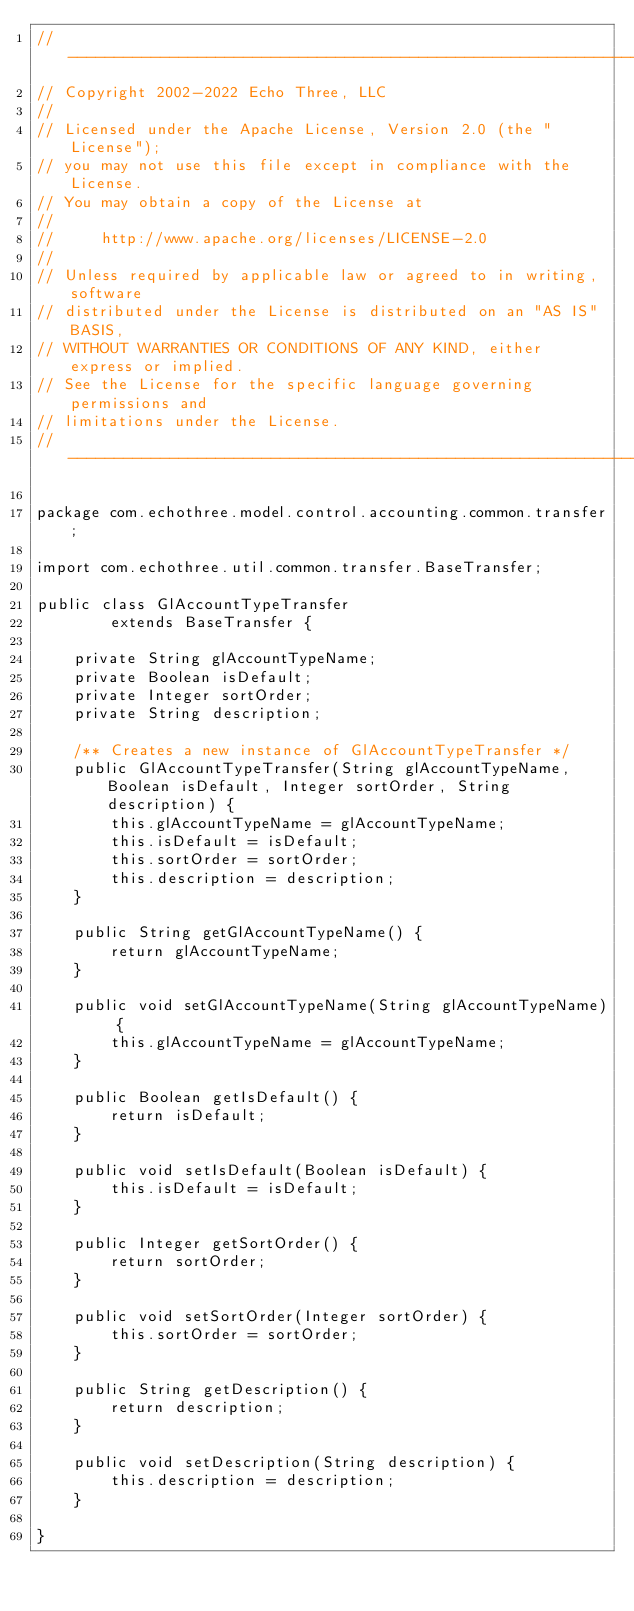Convert code to text. <code><loc_0><loc_0><loc_500><loc_500><_Java_>// --------------------------------------------------------------------------------
// Copyright 2002-2022 Echo Three, LLC
//
// Licensed under the Apache License, Version 2.0 (the "License");
// you may not use this file except in compliance with the License.
// You may obtain a copy of the License at
//
//     http://www.apache.org/licenses/LICENSE-2.0
//
// Unless required by applicable law or agreed to in writing, software
// distributed under the License is distributed on an "AS IS" BASIS,
// WITHOUT WARRANTIES OR CONDITIONS OF ANY KIND, either express or implied.
// See the License for the specific language governing permissions and
// limitations under the License.
// --------------------------------------------------------------------------------

package com.echothree.model.control.accounting.common.transfer;

import com.echothree.util.common.transfer.BaseTransfer;

public class GlAccountTypeTransfer
        extends BaseTransfer {
    
    private String glAccountTypeName;
    private Boolean isDefault;
    private Integer sortOrder;
    private String description;
    
    /** Creates a new instance of GlAccountTypeTransfer */
    public GlAccountTypeTransfer(String glAccountTypeName, Boolean isDefault, Integer sortOrder, String description) {
        this.glAccountTypeName = glAccountTypeName;
        this.isDefault = isDefault;
        this.sortOrder = sortOrder;
        this.description = description;
    }
    
    public String getGlAccountTypeName() {
        return glAccountTypeName;
    }
    
    public void setGlAccountTypeName(String glAccountTypeName) {
        this.glAccountTypeName = glAccountTypeName;
    }
    
    public Boolean getIsDefault() {
        return isDefault;
    }
    
    public void setIsDefault(Boolean isDefault) {
        this.isDefault = isDefault;
    }
    
    public Integer getSortOrder() {
        return sortOrder;
    }
    
    public void setSortOrder(Integer sortOrder) {
        this.sortOrder = sortOrder;
    }
    
    public String getDescription() {
        return description;
    }
    
    public void setDescription(String description) {
        this.description = description;
    }
    
}
</code> 